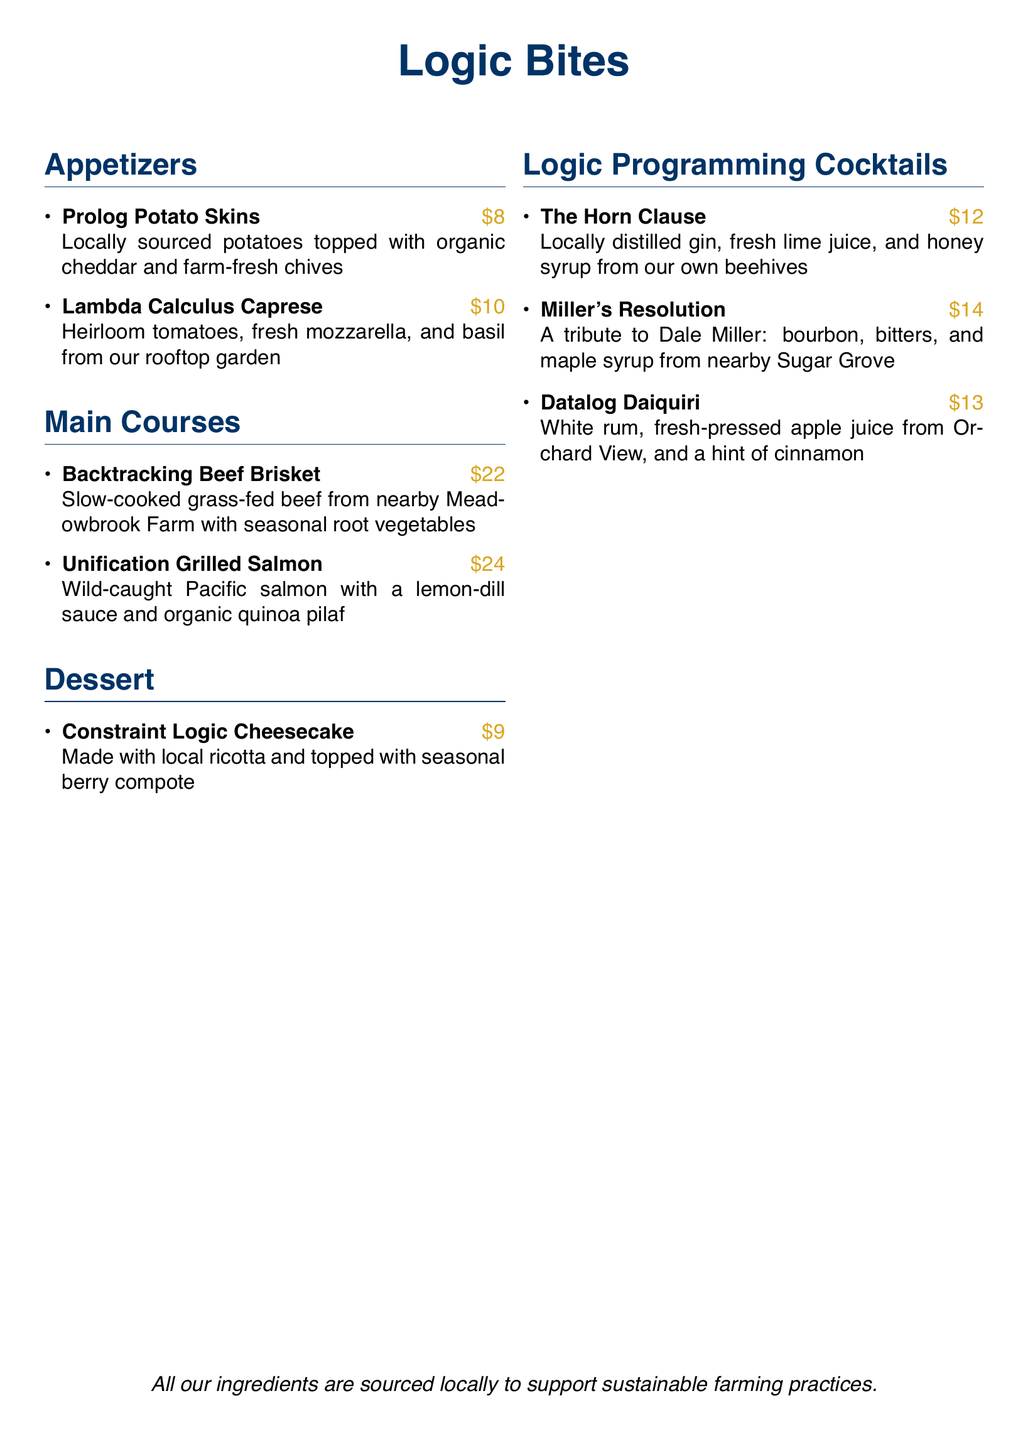what is the price of Prolog Potato Skins? The price of Prolog Potato Skins is listed next to the dish in the menu.
Answer: $8 what is the main ingredient in the Lambda Calculus Caprese? The main ingredient of the Lambda Calculus Caprese dish is provided in the description of the dish.
Answer: heirloom tomatoes how much does the Backtracking Beef Brisket cost? The cost of Backtracking Beef Brisket can be found alongside the dish in the main courses section.
Answer: $22 which cocktail is a tribute to Dale Miller? The cocktails section mentions a tribute to Dale Miller.
Answer: Miller's Resolution what type of fish is used in the Unification Grilled Salmon? The type of fish is specified in the description of the Unification Grilled Salmon.
Answer: Pacific salmon which dessert features seasonal berry compote? The dessert section lists all the desserts, and one of them specifically mentions seasonal berry compote.
Answer: Constraint Logic Cheesecake how many cocktails are listed in the menu? The number of cocktails is determined by counting the items in the Logic Programming Cocktails section.
Answer: 3 what type of cheese is used in the Constraint Logic Cheesecake? The type of cheese is mentioned in the description of the Constraint Logic Cheesecake.
Answer: ricotta what is the main sourcing principle for the ingredients? The last statement in the document indicates the sourcing principle for ingredients.
Answer: sustainable farming practices 